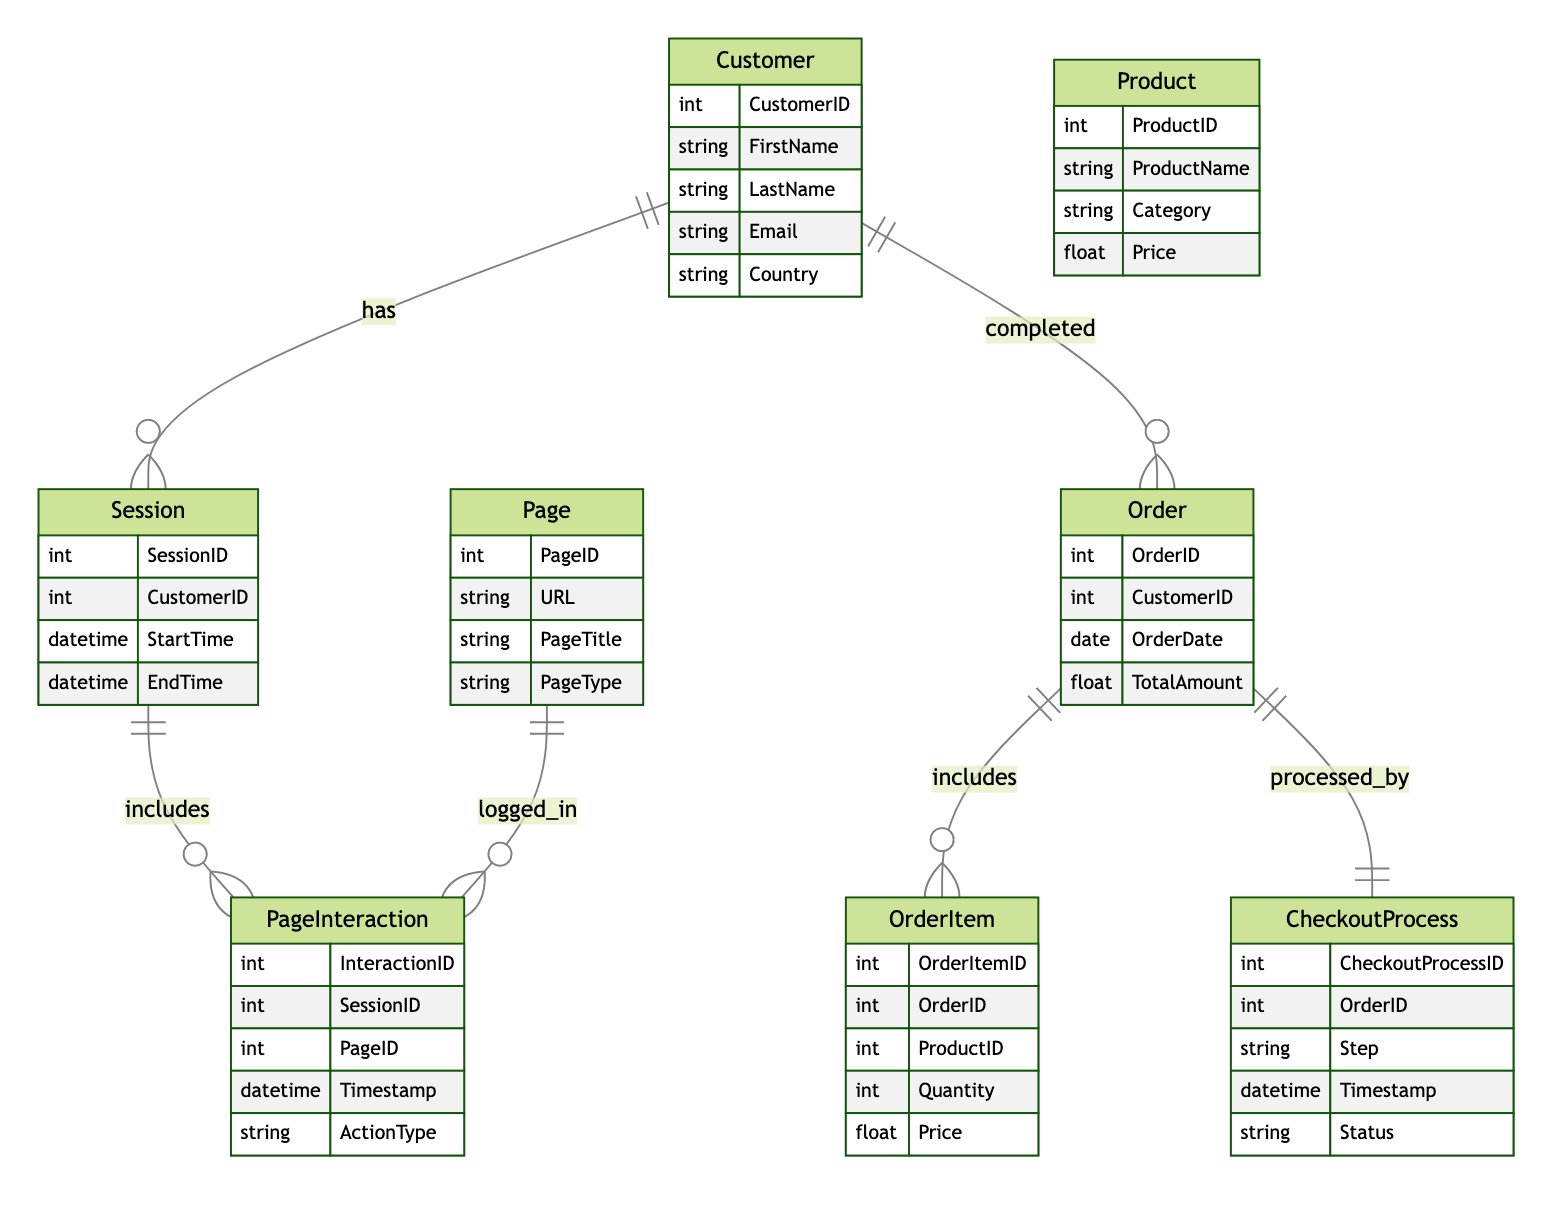What is the relationship between Customer and Session? The diagram shows that a Customer has a one-to-many relationship with Session. This means a single customer can be linked to multiple sessions throughout their interactions on the website.
Answer: one-to-many How many attributes are there in the Order entity? The Order entity has four attributes, which are OrderID, CustomerID, OrderDate, and TotalAmount. By counting these attributes listed in the entity section, we find there are four in total.
Answer: four What entity does the PageInteraction include? The diagram indicates that the Session includes PageInteraction. This represents that each session can consist of multiple page interactions logged during that session.
Answer: PageInteraction What type of relationship exists between Order and CheckoutProcess? There is a one-to-one relationship between Order and CheckoutProcess as described in the diagram. This indicates that each order is processed by exactly one checkout process.
Answer: one-to-one What is the total number of entities in the diagram? The diagram displays a total of seven entities: Customer, Session, Page, PageInteraction, Order, OrderItem, Product, and CheckoutProcess. By counting each distinct entity listed, we find there are seven.
Answer: seven Which entity includes attributes related to products? The Product entity contains attributes specifically related to products, including ProductID, ProductName, Category, and Price. This information specifies details about individual products available in the eCommerce store.
Answer: Product How many types of relationships does the PageInteraction have? The PageInteraction does not have any relationships noted, as it only appears connected to Session and Page through other entities. Therefore, it serves as a connecting point but itself does not have multiple relationships branching from it.
Answer: none What is the URL attribute of the Page entity used for? The URL attribute of the Page entity is used to specify the web address that corresponds to that particular page, allowing tracking of user navigation and interactions on the eCommerce site.
Answer: tracking user navigation What is the attribute indicating the customer’s country? The attribute indicating the customer's country is listed as Country within the Customer entity. This attribute helps identify the geographical location of a customer and can be useful for analytics and targeted marketing.
Answer: Country 